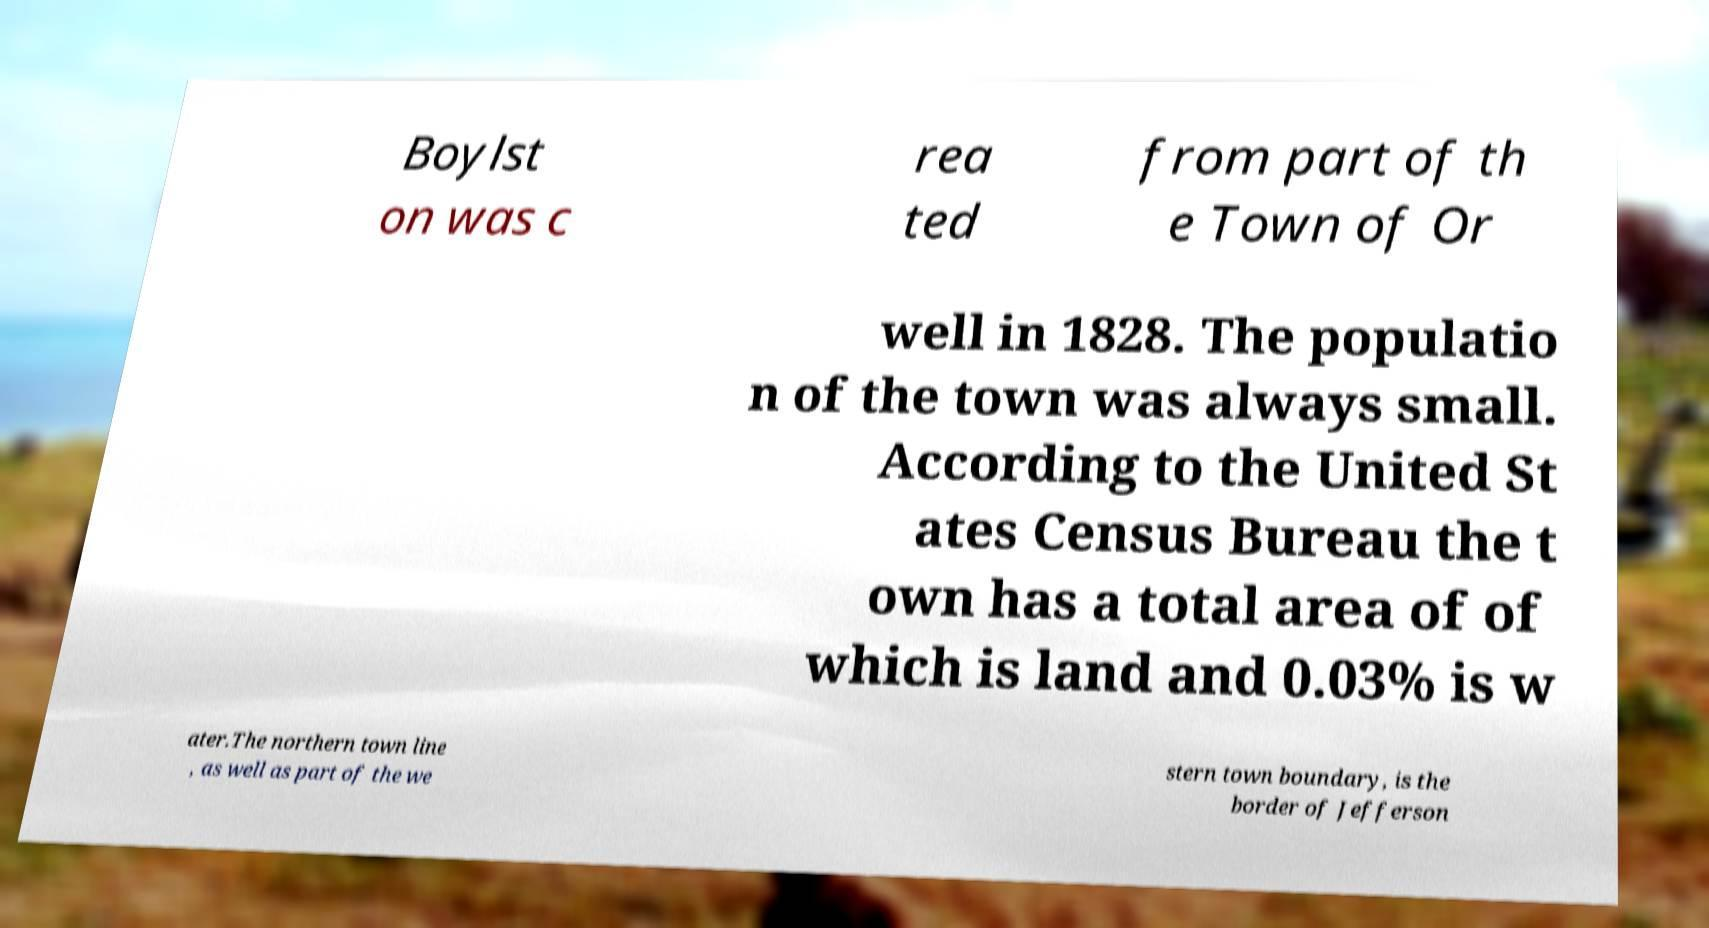For documentation purposes, I need the text within this image transcribed. Could you provide that? Boylst on was c rea ted from part of th e Town of Or well in 1828. The populatio n of the town was always small. According to the United St ates Census Bureau the t own has a total area of of which is land and 0.03% is w ater.The northern town line , as well as part of the we stern town boundary, is the border of Jefferson 